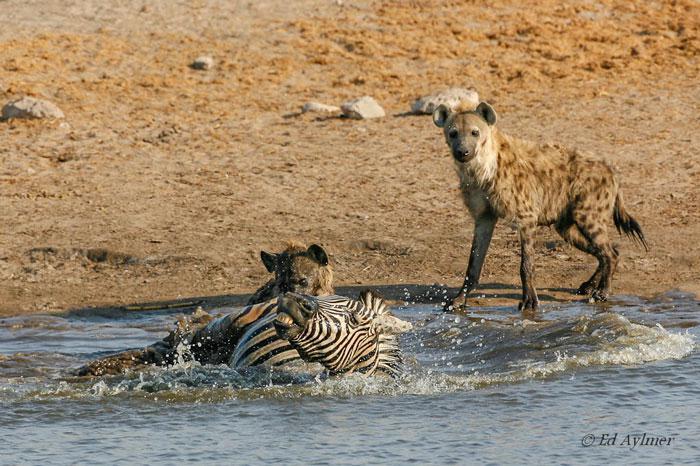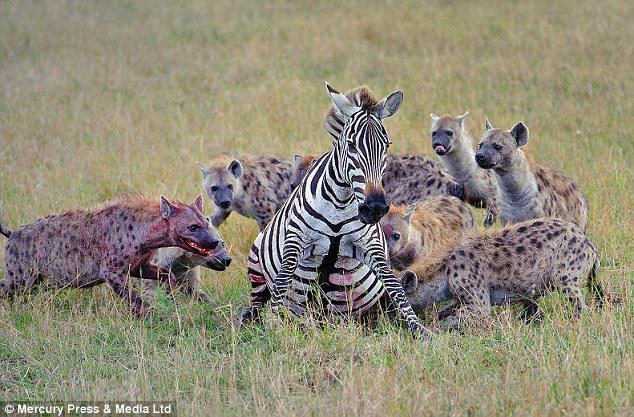The first image is the image on the left, the second image is the image on the right. Examine the images to the left and right. Is the description "A hyena attacks a zebra that is in the water." accurate? Answer yes or no. Yes. 